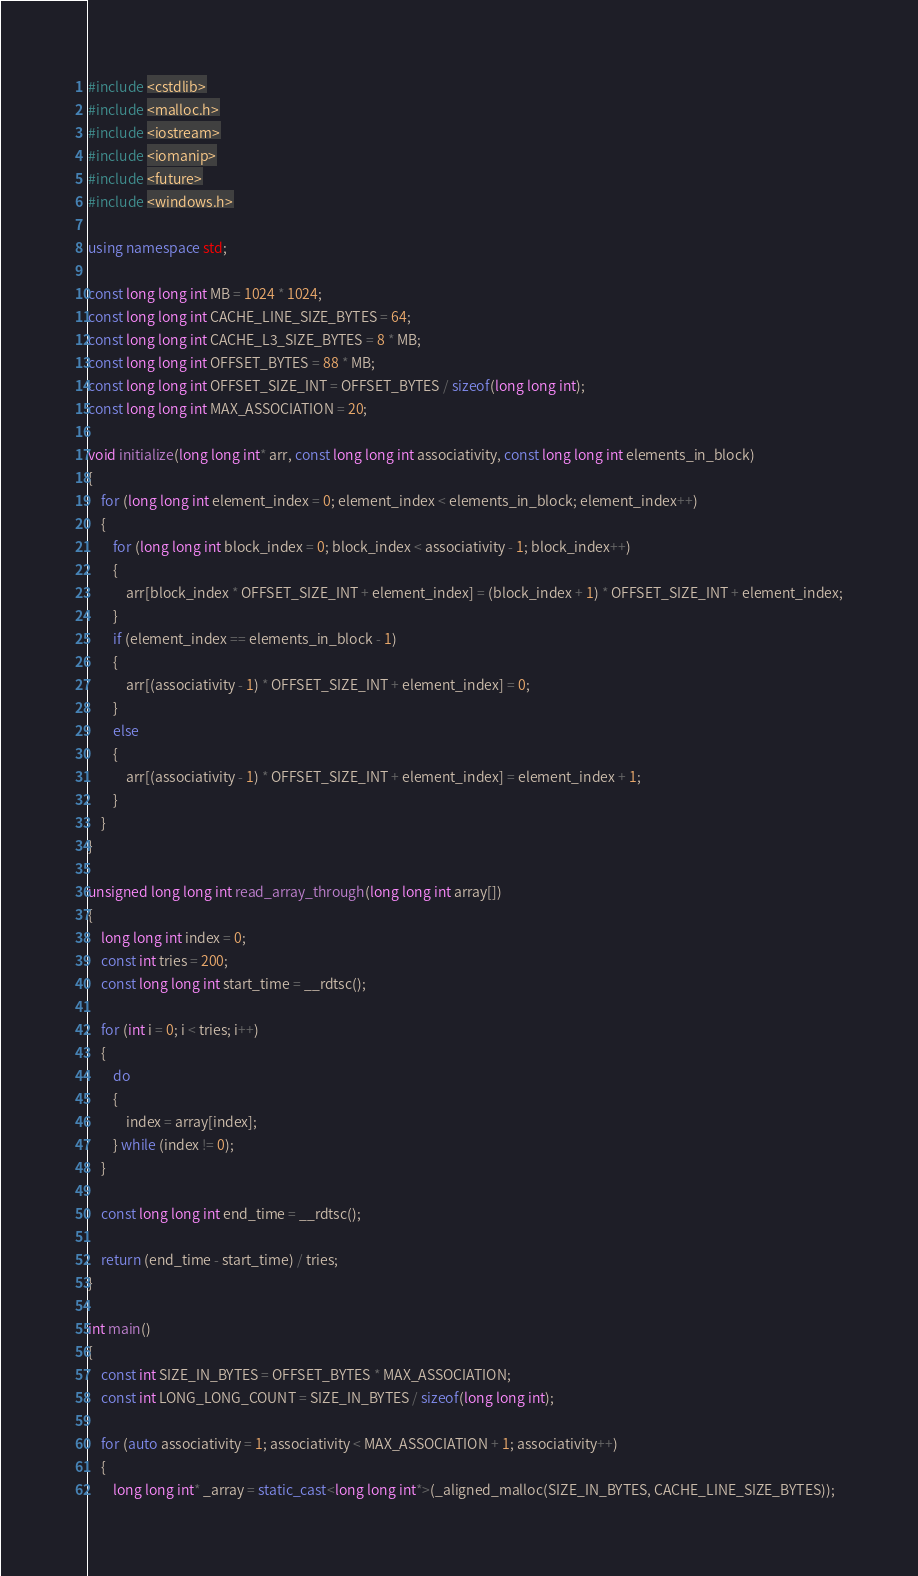<code> <loc_0><loc_0><loc_500><loc_500><_C++_>#include <cstdlib>
#include <malloc.h>
#include <iostream>
#include <iomanip>
#include <future>
#include <windows.h>

using namespace std;

const long long int MB = 1024 * 1024;
const long long int CACHE_LINE_SIZE_BYTES = 64;
const long long int CACHE_L3_SIZE_BYTES = 8 * MB;
const long long int OFFSET_BYTES = 88 * MB;
const long long int OFFSET_SIZE_INT = OFFSET_BYTES / sizeof(long long int);
const long long int MAX_ASSOCIATION = 20;

void initialize(long long int* arr, const long long int associativity, const long long int elements_in_block)
{
	for (long long int element_index = 0; element_index < elements_in_block; element_index++)
	{
		for (long long int block_index = 0; block_index < associativity - 1; block_index++)
		{
			arr[block_index * OFFSET_SIZE_INT + element_index] = (block_index + 1) * OFFSET_SIZE_INT + element_index;
		}
		if (element_index == elements_in_block - 1)
		{
			arr[(associativity - 1) * OFFSET_SIZE_INT + element_index] = 0;
		}
		else
		{
			arr[(associativity - 1) * OFFSET_SIZE_INT + element_index] = element_index + 1;
		}
	}
}

unsigned long long int read_array_through(long long int array[])
{
	long long int index = 0;
	const int tries = 200;
	const long long int start_time = __rdtsc();

	for (int i = 0; i < tries; i++)
	{
		do
		{
			index = array[index];
		} while (index != 0);
	}

	const long long int end_time = __rdtsc();

	return (end_time - start_time) / tries;
}

int main() 
{
	const int SIZE_IN_BYTES = OFFSET_BYTES * MAX_ASSOCIATION;
	const int LONG_LONG_COUNT = SIZE_IN_BYTES / sizeof(long long int);

	for (auto associativity = 1; associativity < MAX_ASSOCIATION + 1; associativity++)
	{
		long long int* _array = static_cast<long long int*>(_aligned_malloc(SIZE_IN_BYTES, CACHE_LINE_SIZE_BYTES));
</code> 